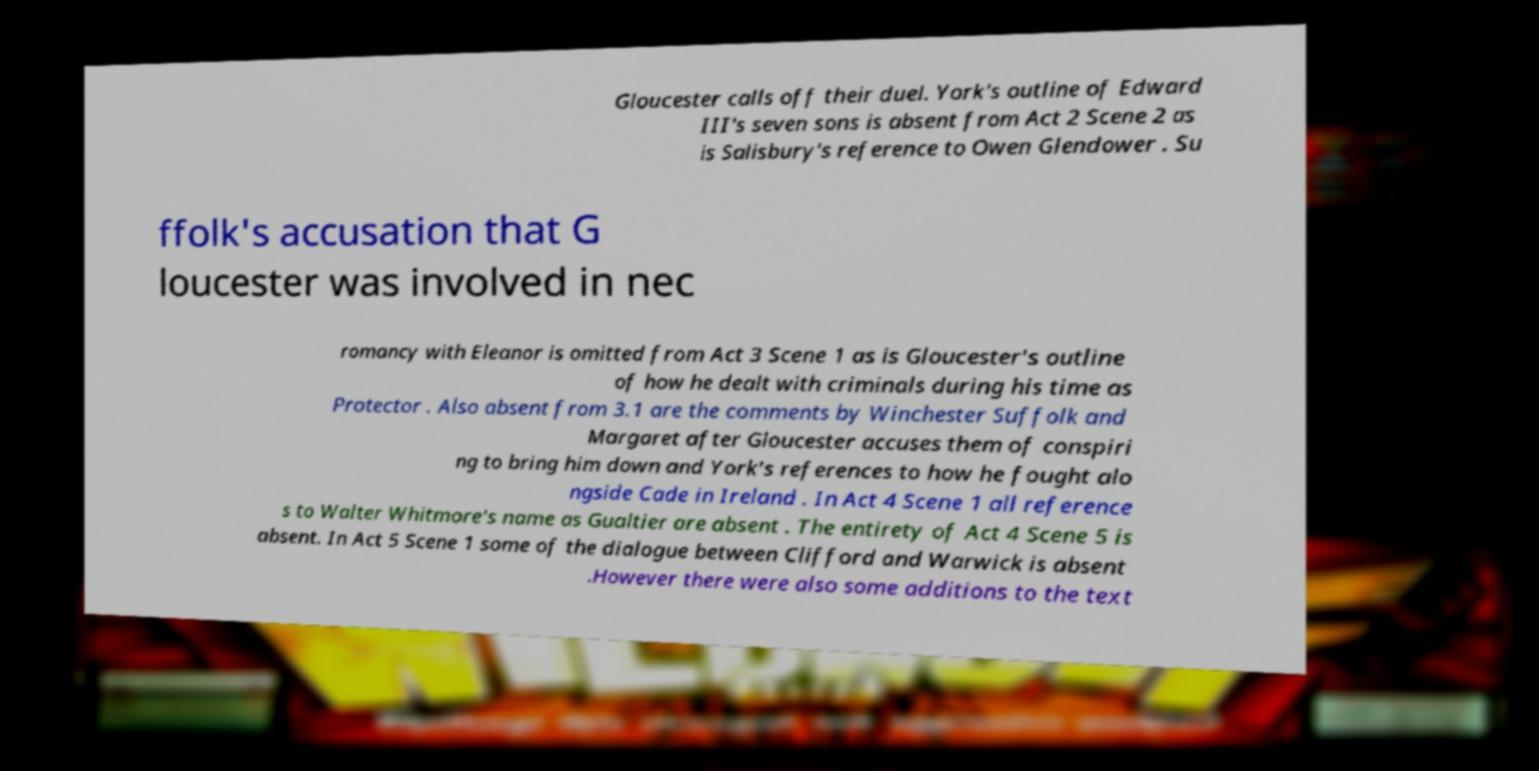Could you extract and type out the text from this image? Gloucester calls off their duel. York's outline of Edward III's seven sons is absent from Act 2 Scene 2 as is Salisbury's reference to Owen Glendower . Su ffolk's accusation that G loucester was involved in nec romancy with Eleanor is omitted from Act 3 Scene 1 as is Gloucester's outline of how he dealt with criminals during his time as Protector . Also absent from 3.1 are the comments by Winchester Suffolk and Margaret after Gloucester accuses them of conspiri ng to bring him down and York's references to how he fought alo ngside Cade in Ireland . In Act 4 Scene 1 all reference s to Walter Whitmore's name as Gualtier are absent . The entirety of Act 4 Scene 5 is absent. In Act 5 Scene 1 some of the dialogue between Clifford and Warwick is absent .However there were also some additions to the text 